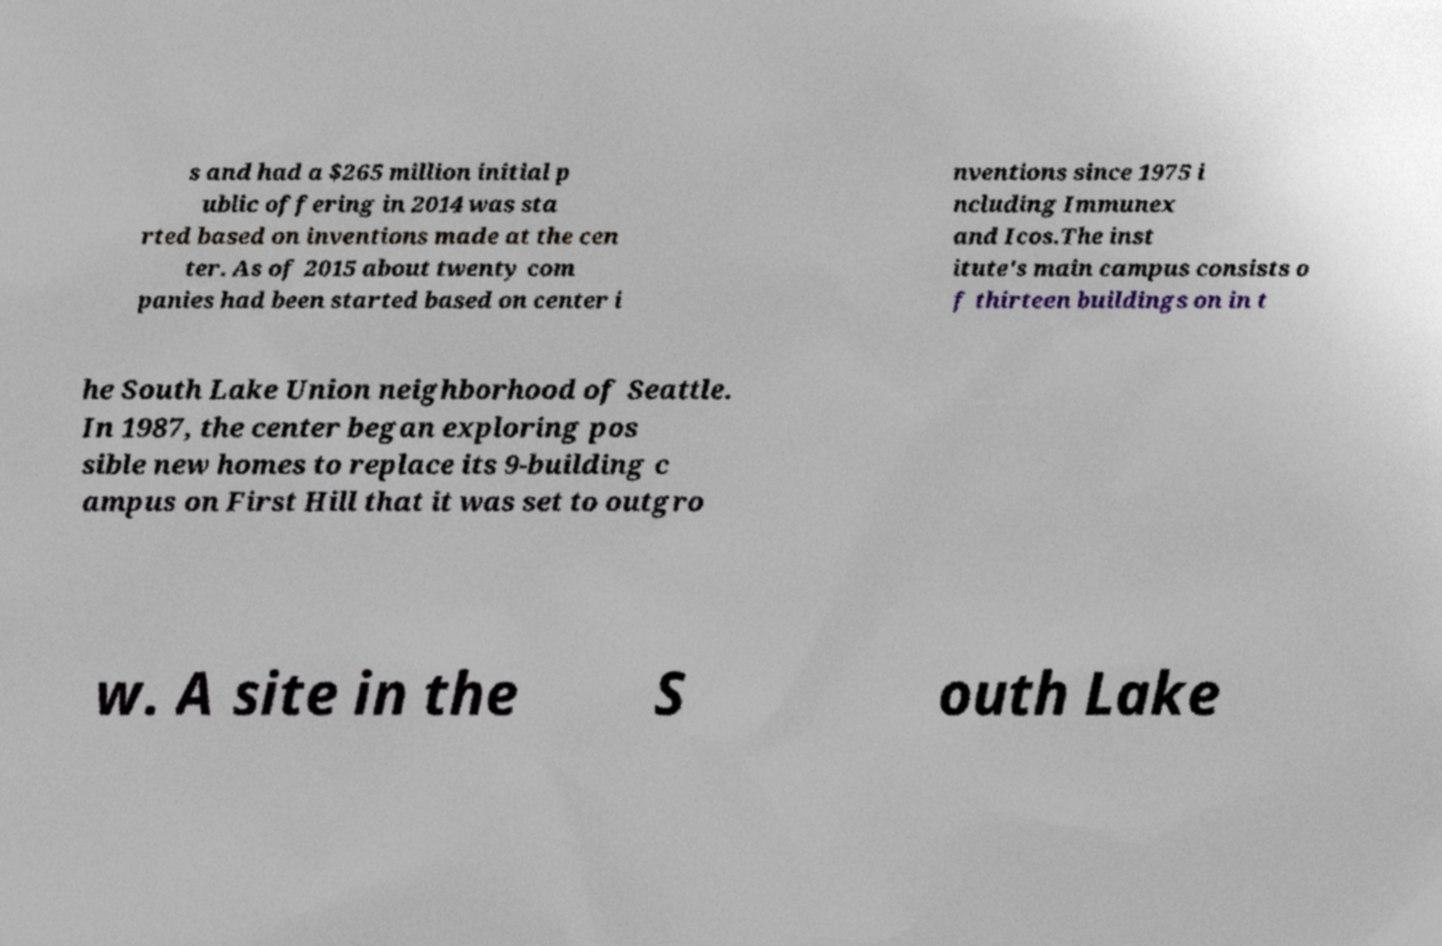Please read and relay the text visible in this image. What does it say? s and had a $265 million initial p ublic offering in 2014 was sta rted based on inventions made at the cen ter. As of 2015 about twenty com panies had been started based on center i nventions since 1975 i ncluding Immunex and Icos.The inst itute's main campus consists o f thirteen buildings on in t he South Lake Union neighborhood of Seattle. In 1987, the center began exploring pos sible new homes to replace its 9-building c ampus on First Hill that it was set to outgro w. A site in the S outh Lake 